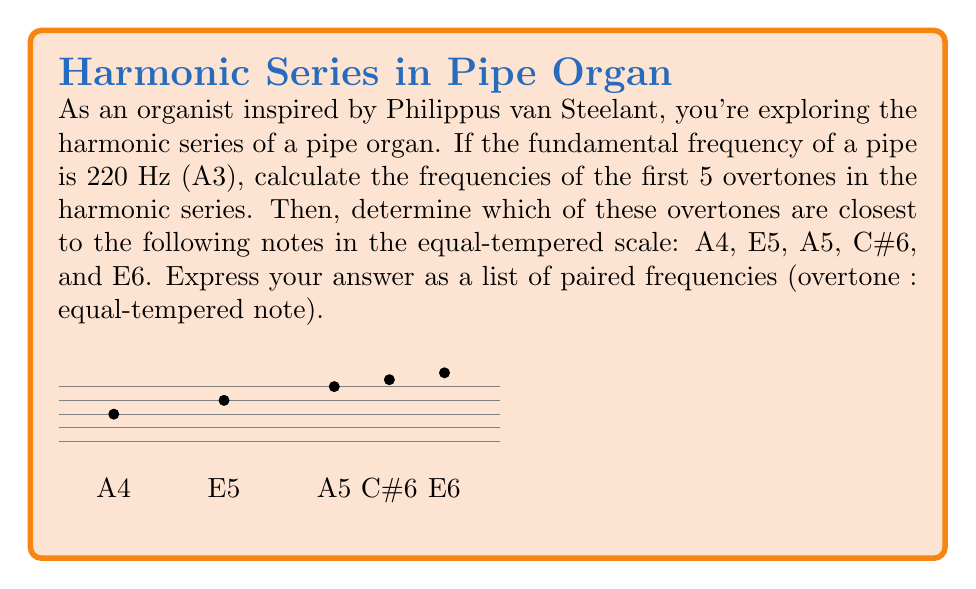Help me with this question. Let's approach this step-by-step:

1) The harmonic series is given by the formula:
   $$f_n = n \cdot f_1$$
   where $f_1$ is the fundamental frequency and $n$ is the harmonic number.

2) Given $f_1 = 220$ Hz, we can calculate the first 5 overtones:
   
   2nd harmonic (1st overtone): $f_2 = 2 \cdot 220 = 440$ Hz
   3rd harmonic (2nd overtone): $f_3 = 3 \cdot 220 = 660$ Hz
   4th harmonic (3rd overtone): $f_4 = 4 \cdot 220 = 880$ Hz
   5th harmonic (4th overtone): $f_5 = 5 \cdot 220 = 1100$ Hz
   6th harmonic (5th overtone): $f_6 = 6 \cdot 220 = 1320$ Hz

3) Now, let's calculate the frequencies of the given notes in the equal-tempered scale:
   
   A4: $440$ Hz (by definition)
   E5: $440 \cdot 2^{\frac{7}{12}} \approx 659.25$ Hz
   A5: $440 \cdot 2^{\frac{12}{12}} = 880$ Hz
   C#6: $440 \cdot 2^{\frac{16}{12}} \approx 1108.73$ Hz
   E6: $440 \cdot 2^{\frac{19}{12}} \approx 1318.51$ Hz

4) Matching the overtones to the closest equal-tempered notes:

   440 Hz (1st overtone) : 440 Hz (A4)
   660 Hz (2nd overtone) : 659.25 Hz (E5)
   880 Hz (3rd overtone) : 880 Hz (A5)
   1100 Hz (4th overtone) : 1108.73 Hz (C#6)
   1320 Hz (5th overtone) : 1318.51 Hz (E6)
Answer: $$(440:440), (660:659.25), (880:880), (1100:1108.73), (1320:1318.51)$$ 